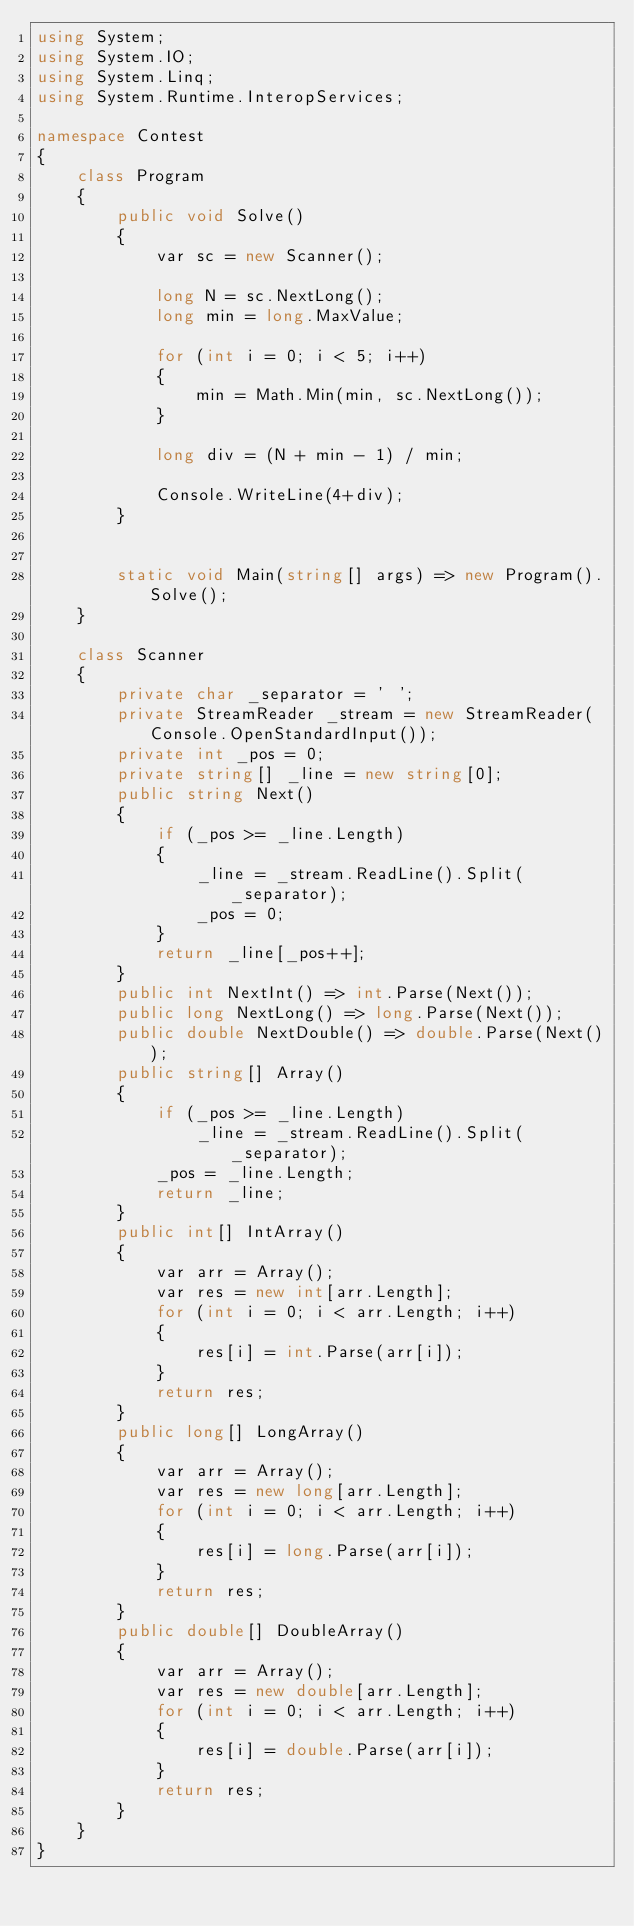Convert code to text. <code><loc_0><loc_0><loc_500><loc_500><_C#_>using System;
using System.IO;
using System.Linq;
using System.Runtime.InteropServices;

namespace Contest
{
    class Program
    {
        public void Solve()
        {
            var sc = new Scanner();

            long N = sc.NextLong();
            long min = long.MaxValue;

            for (int i = 0; i < 5; i++)
            {
                min = Math.Min(min, sc.NextLong());
            }

            long div = (N + min - 1) / min;

            Console.WriteLine(4+div);
        }


        static void Main(string[] args) => new Program().Solve();
    }

    class Scanner
    {
        private char _separator = ' ';
        private StreamReader _stream = new StreamReader(Console.OpenStandardInput());
        private int _pos = 0;
        private string[] _line = new string[0];
        public string Next()
        {
            if (_pos >= _line.Length)
            {
                _line = _stream.ReadLine().Split(_separator);
                _pos = 0;
            }
            return _line[_pos++];
        }
        public int NextInt() => int.Parse(Next());
        public long NextLong() => long.Parse(Next());
        public double NextDouble() => double.Parse(Next());
        public string[] Array()
        {
            if (_pos >= _line.Length)
                _line = _stream.ReadLine().Split(_separator);
            _pos = _line.Length;
            return _line;
        }
        public int[] IntArray()
        {
            var arr = Array();
            var res = new int[arr.Length];
            for (int i = 0; i < arr.Length; i++)
            {
                res[i] = int.Parse(arr[i]);
            }
            return res;
        }
        public long[] LongArray()
        {
            var arr = Array();
            var res = new long[arr.Length];
            for (int i = 0; i < arr.Length; i++)
            {
                res[i] = long.Parse(arr[i]);
            }
            return res;
        }
        public double[] DoubleArray()
        {
            var arr = Array();
            var res = new double[arr.Length];
            for (int i = 0; i < arr.Length; i++)
            {
                res[i] = double.Parse(arr[i]);
            }
            return res;
        }
    }
}
</code> 